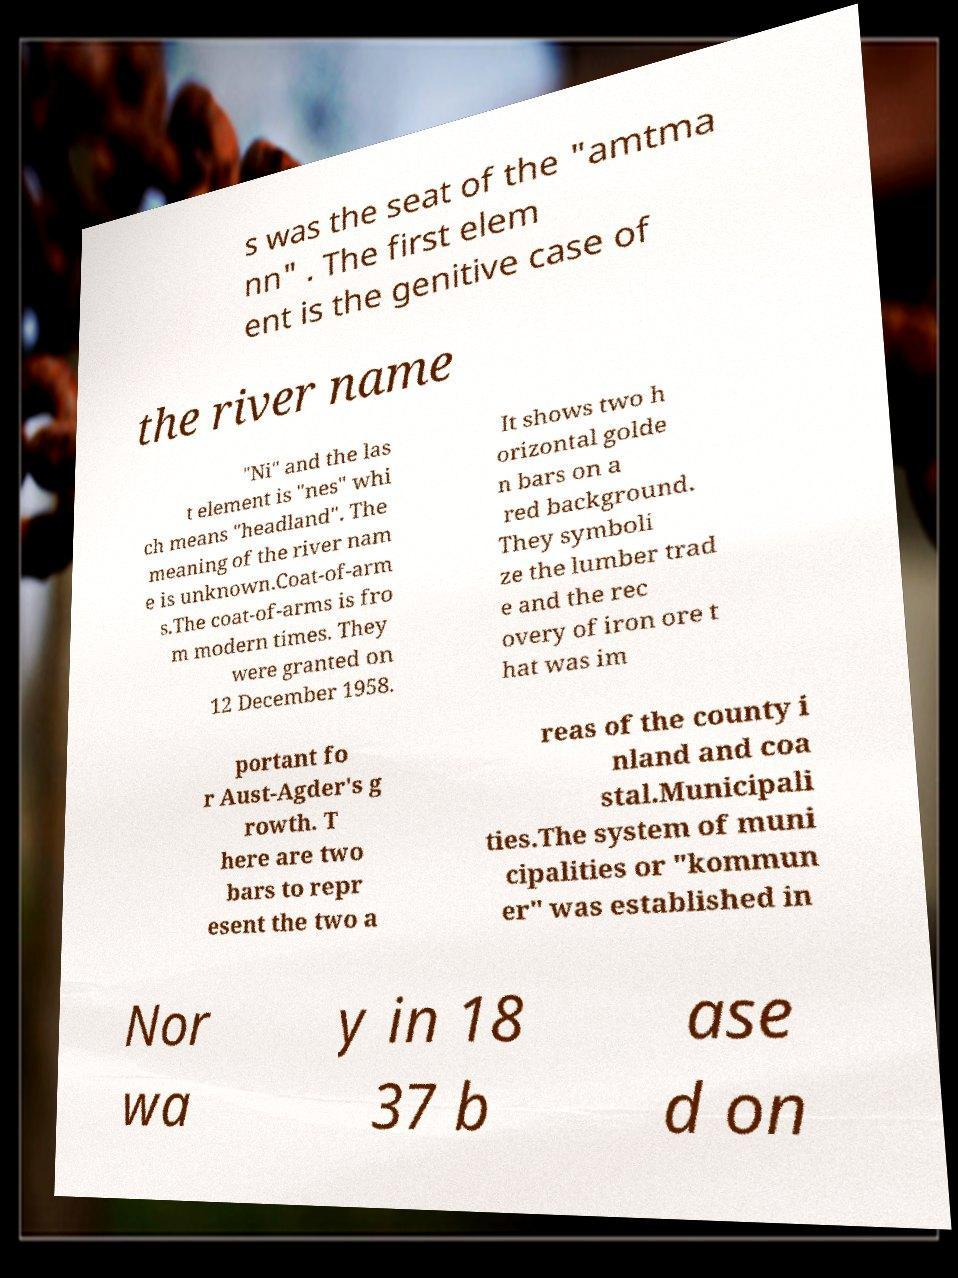For documentation purposes, I need the text within this image transcribed. Could you provide that? s was the seat of the "amtma nn" . The first elem ent is the genitive case of the river name "Ni" and the las t element is "nes" whi ch means "headland". The meaning of the river nam e is unknown.Coat-of-arm s.The coat-of-arms is fro m modern times. They were granted on 12 December 1958. It shows two h orizontal golde n bars on a red background. They symboli ze the lumber trad e and the rec overy of iron ore t hat was im portant fo r Aust-Agder's g rowth. T here are two bars to repr esent the two a reas of the county i nland and coa stal.Municipali ties.The system of muni cipalities or "kommun er" was established in Nor wa y in 18 37 b ase d on 